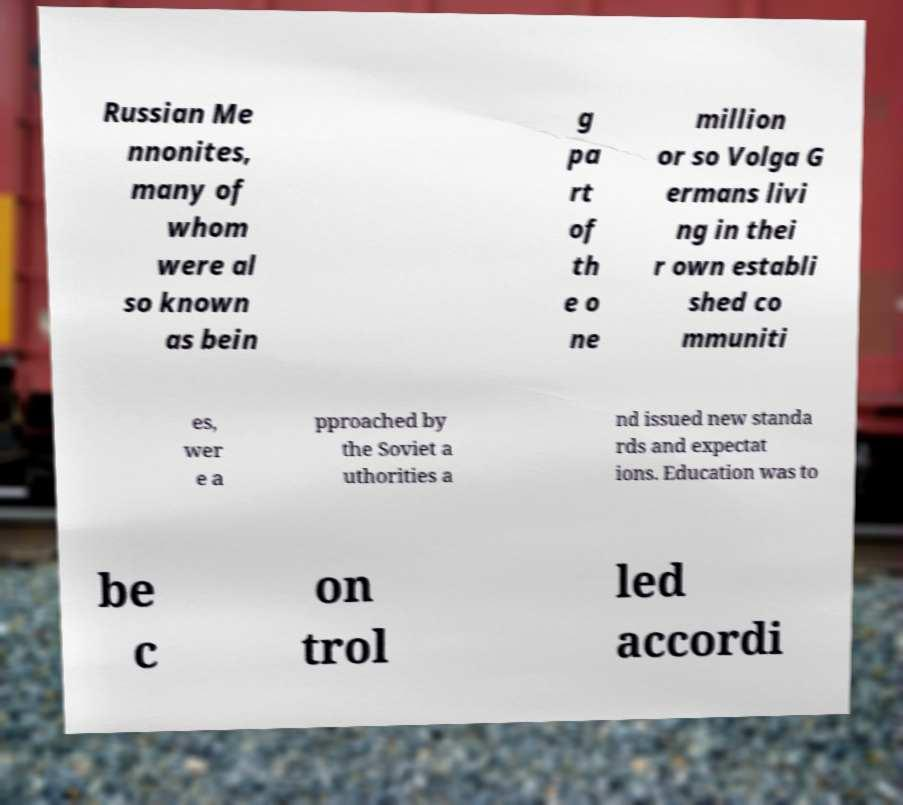What messages or text are displayed in this image? I need them in a readable, typed format. Russian Me nnonites, many of whom were al so known as bein g pa rt of th e o ne million or so Volga G ermans livi ng in thei r own establi shed co mmuniti es, wer e a pproached by the Soviet a uthorities a nd issued new standa rds and expectat ions. Education was to be c on trol led accordi 